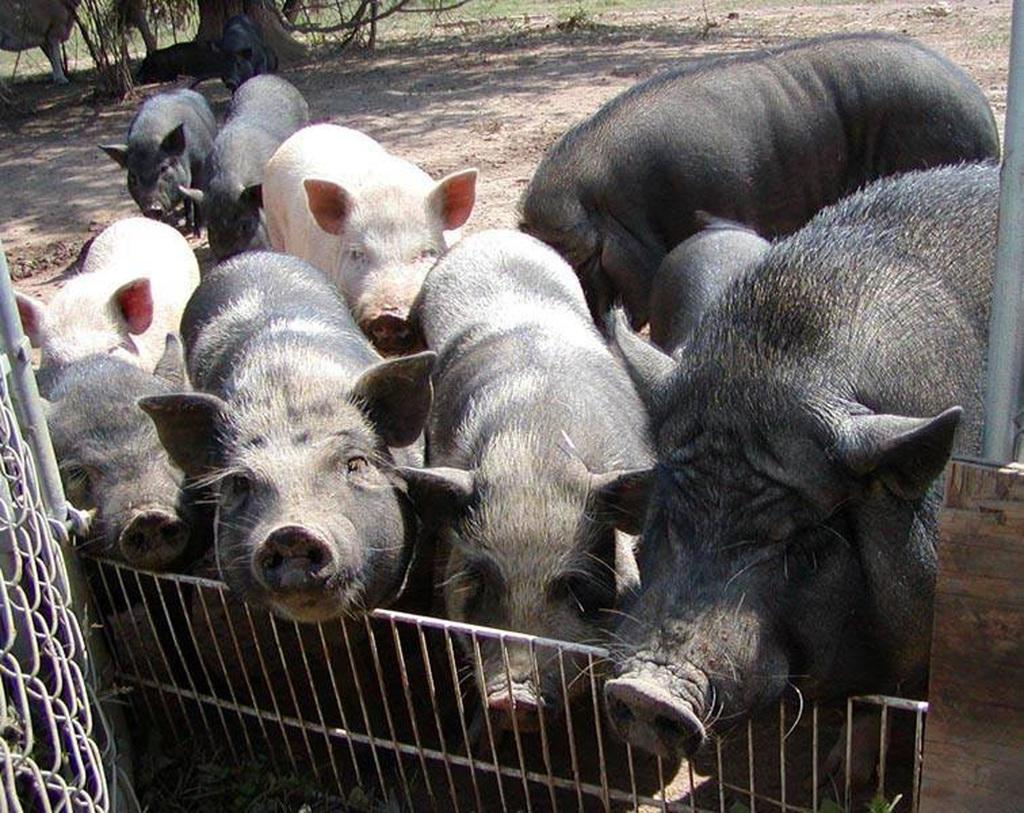What animals are present in the image? There are pigs in the image. What colors can be seen on the pigs? The pigs have black and red colors. What type of barrier is visible at the bottom of the image? There is an iron fence at the bottom of the image. What type of agreement can be seen being signed by the pigs in the image? There is no agreement being signed by the pigs in the image; they are simply pigs with black and red colors. 